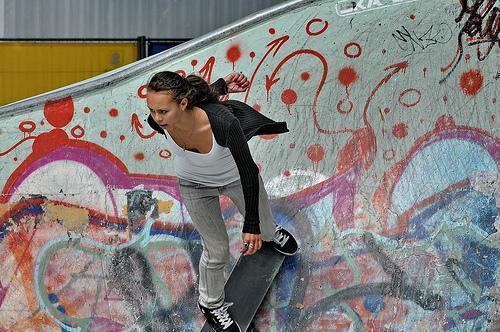How many skateboards are in the picture?
Give a very brief answer. 1. 